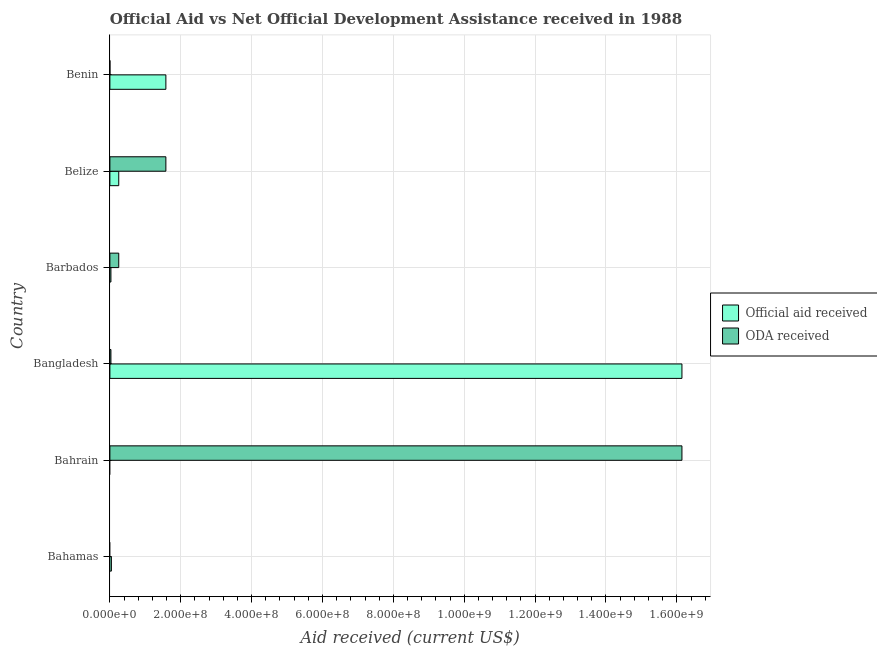Are the number of bars per tick equal to the number of legend labels?
Keep it short and to the point. No. How many bars are there on the 4th tick from the bottom?
Offer a terse response. 2. What is the label of the 6th group of bars from the top?
Give a very brief answer. Bahamas. What is the official aid received in Bahamas?
Your answer should be very brief. 4.24e+06. Across all countries, what is the maximum official aid received?
Offer a very short reply. 1.61e+09. In which country was the official aid received maximum?
Provide a succinct answer. Bangladesh. What is the total oda received in the graph?
Keep it short and to the point. 1.80e+09. What is the difference between the official aid received in Barbados and that in Benin?
Your answer should be compact. -1.55e+08. What is the difference between the official aid received in Barbados and the oda received in Bahamas?
Offer a terse response. 2.90e+06. What is the average official aid received per country?
Give a very brief answer. 3.01e+08. What is the difference between the oda received and official aid received in Benin?
Offer a terse response. -1.58e+08. What is the ratio of the official aid received in Bangladesh to that in Belize?
Ensure brevity in your answer.  64.55. Is the oda received in Bahrain less than that in Belize?
Keep it short and to the point. No. What is the difference between the highest and the second highest oda received?
Your answer should be compact. 1.46e+09. What is the difference between the highest and the lowest official aid received?
Give a very brief answer. 1.61e+09. How many countries are there in the graph?
Offer a terse response. 6. What is the difference between two consecutive major ticks on the X-axis?
Ensure brevity in your answer.  2.00e+08. Where does the legend appear in the graph?
Your answer should be very brief. Center right. How many legend labels are there?
Ensure brevity in your answer.  2. What is the title of the graph?
Keep it short and to the point. Official Aid vs Net Official Development Assistance received in 1988 . What is the label or title of the X-axis?
Provide a short and direct response. Aid received (current US$). What is the label or title of the Y-axis?
Ensure brevity in your answer.  Country. What is the Aid received (current US$) in Official aid received in Bahamas?
Your answer should be compact. 4.24e+06. What is the Aid received (current US$) in ODA received in Bahrain?
Provide a short and direct response. 1.61e+09. What is the Aid received (current US$) in Official aid received in Bangladesh?
Your answer should be very brief. 1.61e+09. What is the Aid received (current US$) in ODA received in Bangladesh?
Your answer should be very brief. 2.90e+06. What is the Aid received (current US$) of Official aid received in Barbados?
Make the answer very short. 2.90e+06. What is the Aid received (current US$) of ODA received in Barbados?
Provide a succinct answer. 2.50e+07. What is the Aid received (current US$) of Official aid received in Belize?
Your answer should be very brief. 2.50e+07. What is the Aid received (current US$) in ODA received in Belize?
Ensure brevity in your answer.  1.58e+08. What is the Aid received (current US$) in Official aid received in Benin?
Your answer should be very brief. 1.58e+08. Across all countries, what is the maximum Aid received (current US$) of Official aid received?
Give a very brief answer. 1.61e+09. Across all countries, what is the maximum Aid received (current US$) in ODA received?
Keep it short and to the point. 1.61e+09. Across all countries, what is the minimum Aid received (current US$) of ODA received?
Give a very brief answer. 0. What is the total Aid received (current US$) in Official aid received in the graph?
Keep it short and to the point. 1.80e+09. What is the total Aid received (current US$) of ODA received in the graph?
Offer a very short reply. 1.80e+09. What is the difference between the Aid received (current US$) in Official aid received in Bahamas and that in Bangladesh?
Keep it short and to the point. -1.61e+09. What is the difference between the Aid received (current US$) of Official aid received in Bahamas and that in Barbados?
Provide a succinct answer. 1.34e+06. What is the difference between the Aid received (current US$) of Official aid received in Bahamas and that in Belize?
Your answer should be very brief. -2.08e+07. What is the difference between the Aid received (current US$) of Official aid received in Bahamas and that in Benin?
Give a very brief answer. -1.54e+08. What is the difference between the Aid received (current US$) of ODA received in Bahrain and that in Bangladesh?
Give a very brief answer. 1.61e+09. What is the difference between the Aid received (current US$) of ODA received in Bahrain and that in Barbados?
Provide a short and direct response. 1.59e+09. What is the difference between the Aid received (current US$) in ODA received in Bahrain and that in Belize?
Make the answer very short. 1.46e+09. What is the difference between the Aid received (current US$) of ODA received in Bahrain and that in Benin?
Give a very brief answer. 1.61e+09. What is the difference between the Aid received (current US$) in Official aid received in Bangladesh and that in Barbados?
Give a very brief answer. 1.61e+09. What is the difference between the Aid received (current US$) of ODA received in Bangladesh and that in Barbados?
Your answer should be very brief. -2.21e+07. What is the difference between the Aid received (current US$) in Official aid received in Bangladesh and that in Belize?
Ensure brevity in your answer.  1.59e+09. What is the difference between the Aid received (current US$) in ODA received in Bangladesh and that in Belize?
Offer a very short reply. -1.55e+08. What is the difference between the Aid received (current US$) in Official aid received in Bangladesh and that in Benin?
Provide a succinct answer. 1.46e+09. What is the difference between the Aid received (current US$) of ODA received in Bangladesh and that in Benin?
Give a very brief answer. 2.86e+06. What is the difference between the Aid received (current US$) in Official aid received in Barbados and that in Belize?
Give a very brief answer. -2.21e+07. What is the difference between the Aid received (current US$) of ODA received in Barbados and that in Belize?
Your response must be concise. -1.33e+08. What is the difference between the Aid received (current US$) of Official aid received in Barbados and that in Benin?
Make the answer very short. -1.55e+08. What is the difference between the Aid received (current US$) of ODA received in Barbados and that in Benin?
Offer a very short reply. 2.50e+07. What is the difference between the Aid received (current US$) in Official aid received in Belize and that in Benin?
Your response must be concise. -1.33e+08. What is the difference between the Aid received (current US$) of ODA received in Belize and that in Benin?
Ensure brevity in your answer.  1.58e+08. What is the difference between the Aid received (current US$) in Official aid received in Bahamas and the Aid received (current US$) in ODA received in Bahrain?
Make the answer very short. -1.61e+09. What is the difference between the Aid received (current US$) of Official aid received in Bahamas and the Aid received (current US$) of ODA received in Bangladesh?
Your response must be concise. 1.34e+06. What is the difference between the Aid received (current US$) of Official aid received in Bahamas and the Aid received (current US$) of ODA received in Barbados?
Your response must be concise. -2.08e+07. What is the difference between the Aid received (current US$) in Official aid received in Bahamas and the Aid received (current US$) in ODA received in Belize?
Your response must be concise. -1.54e+08. What is the difference between the Aid received (current US$) of Official aid received in Bahamas and the Aid received (current US$) of ODA received in Benin?
Provide a succinct answer. 4.20e+06. What is the difference between the Aid received (current US$) of Official aid received in Bangladesh and the Aid received (current US$) of ODA received in Barbados?
Provide a succinct answer. 1.59e+09. What is the difference between the Aid received (current US$) in Official aid received in Bangladesh and the Aid received (current US$) in ODA received in Belize?
Your answer should be very brief. 1.46e+09. What is the difference between the Aid received (current US$) in Official aid received in Bangladesh and the Aid received (current US$) in ODA received in Benin?
Offer a very short reply. 1.61e+09. What is the difference between the Aid received (current US$) in Official aid received in Barbados and the Aid received (current US$) in ODA received in Belize?
Offer a very short reply. -1.55e+08. What is the difference between the Aid received (current US$) of Official aid received in Barbados and the Aid received (current US$) of ODA received in Benin?
Offer a very short reply. 2.86e+06. What is the difference between the Aid received (current US$) of Official aid received in Belize and the Aid received (current US$) of ODA received in Benin?
Provide a succinct answer. 2.50e+07. What is the average Aid received (current US$) of Official aid received per country?
Your answer should be very brief. 3.01e+08. What is the average Aid received (current US$) of ODA received per country?
Ensure brevity in your answer.  3.00e+08. What is the difference between the Aid received (current US$) in Official aid received and Aid received (current US$) in ODA received in Bangladesh?
Your answer should be compact. 1.61e+09. What is the difference between the Aid received (current US$) of Official aid received and Aid received (current US$) of ODA received in Barbados?
Offer a very short reply. -2.21e+07. What is the difference between the Aid received (current US$) in Official aid received and Aid received (current US$) in ODA received in Belize?
Offer a very short reply. -1.33e+08. What is the difference between the Aid received (current US$) of Official aid received and Aid received (current US$) of ODA received in Benin?
Ensure brevity in your answer.  1.58e+08. What is the ratio of the Aid received (current US$) in Official aid received in Bahamas to that in Bangladesh?
Provide a succinct answer. 0. What is the ratio of the Aid received (current US$) of Official aid received in Bahamas to that in Barbados?
Your answer should be very brief. 1.46. What is the ratio of the Aid received (current US$) of Official aid received in Bahamas to that in Belize?
Your answer should be compact. 0.17. What is the ratio of the Aid received (current US$) of Official aid received in Bahamas to that in Benin?
Your response must be concise. 0.03. What is the ratio of the Aid received (current US$) in ODA received in Bahrain to that in Bangladesh?
Your response must be concise. 556.68. What is the ratio of the Aid received (current US$) of ODA received in Bahrain to that in Barbados?
Provide a short and direct response. 64.55. What is the ratio of the Aid received (current US$) in ODA received in Bahrain to that in Belize?
Provide a succinct answer. 10.22. What is the ratio of the Aid received (current US$) in ODA received in Bahrain to that in Benin?
Your response must be concise. 4.04e+04. What is the ratio of the Aid received (current US$) of Official aid received in Bangladesh to that in Barbados?
Provide a short and direct response. 556.68. What is the ratio of the Aid received (current US$) in ODA received in Bangladesh to that in Barbados?
Your answer should be compact. 0.12. What is the ratio of the Aid received (current US$) of Official aid received in Bangladesh to that in Belize?
Your response must be concise. 64.55. What is the ratio of the Aid received (current US$) in ODA received in Bangladesh to that in Belize?
Ensure brevity in your answer.  0.02. What is the ratio of the Aid received (current US$) in Official aid received in Bangladesh to that in Benin?
Your answer should be compact. 10.22. What is the ratio of the Aid received (current US$) of ODA received in Bangladesh to that in Benin?
Make the answer very short. 72.5. What is the ratio of the Aid received (current US$) of Official aid received in Barbados to that in Belize?
Provide a short and direct response. 0.12. What is the ratio of the Aid received (current US$) of ODA received in Barbados to that in Belize?
Your response must be concise. 0.16. What is the ratio of the Aid received (current US$) in Official aid received in Barbados to that in Benin?
Keep it short and to the point. 0.02. What is the ratio of the Aid received (current US$) in ODA received in Barbados to that in Benin?
Offer a very short reply. 625.25. What is the ratio of the Aid received (current US$) of Official aid received in Belize to that in Benin?
Your answer should be very brief. 0.16. What is the ratio of the Aid received (current US$) in ODA received in Belize to that in Benin?
Your answer should be compact. 3949.25. What is the difference between the highest and the second highest Aid received (current US$) in Official aid received?
Make the answer very short. 1.46e+09. What is the difference between the highest and the second highest Aid received (current US$) in ODA received?
Give a very brief answer. 1.46e+09. What is the difference between the highest and the lowest Aid received (current US$) of Official aid received?
Make the answer very short. 1.61e+09. What is the difference between the highest and the lowest Aid received (current US$) in ODA received?
Your answer should be compact. 1.61e+09. 